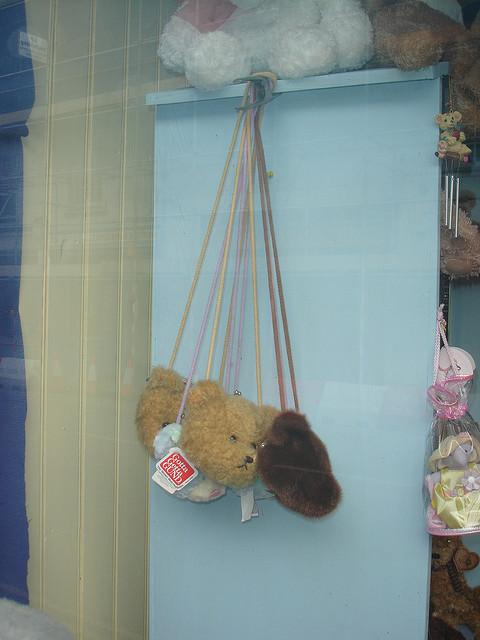What is the bear here doing?

Choices:
A) running
B) hanging
C) eating
D) jumping hanging 